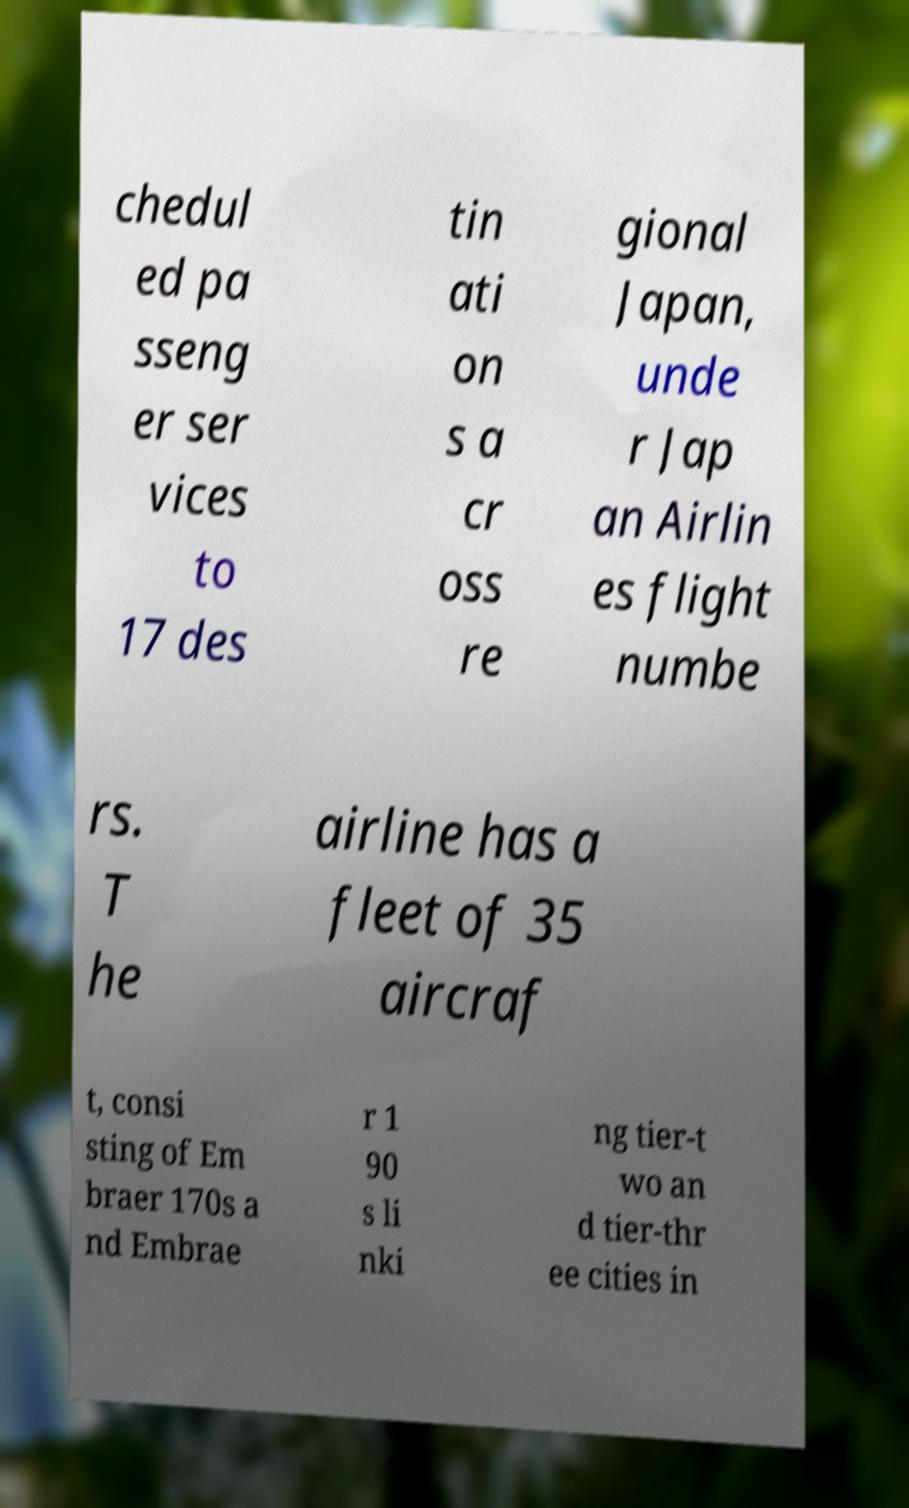Can you read and provide the text displayed in the image?This photo seems to have some interesting text. Can you extract and type it out for me? chedul ed pa sseng er ser vices to 17 des tin ati on s a cr oss re gional Japan, unde r Jap an Airlin es flight numbe rs. T he airline has a fleet of 35 aircraf t, consi sting of Em braer 170s a nd Embrae r 1 90 s li nki ng tier-t wo an d tier-thr ee cities in 